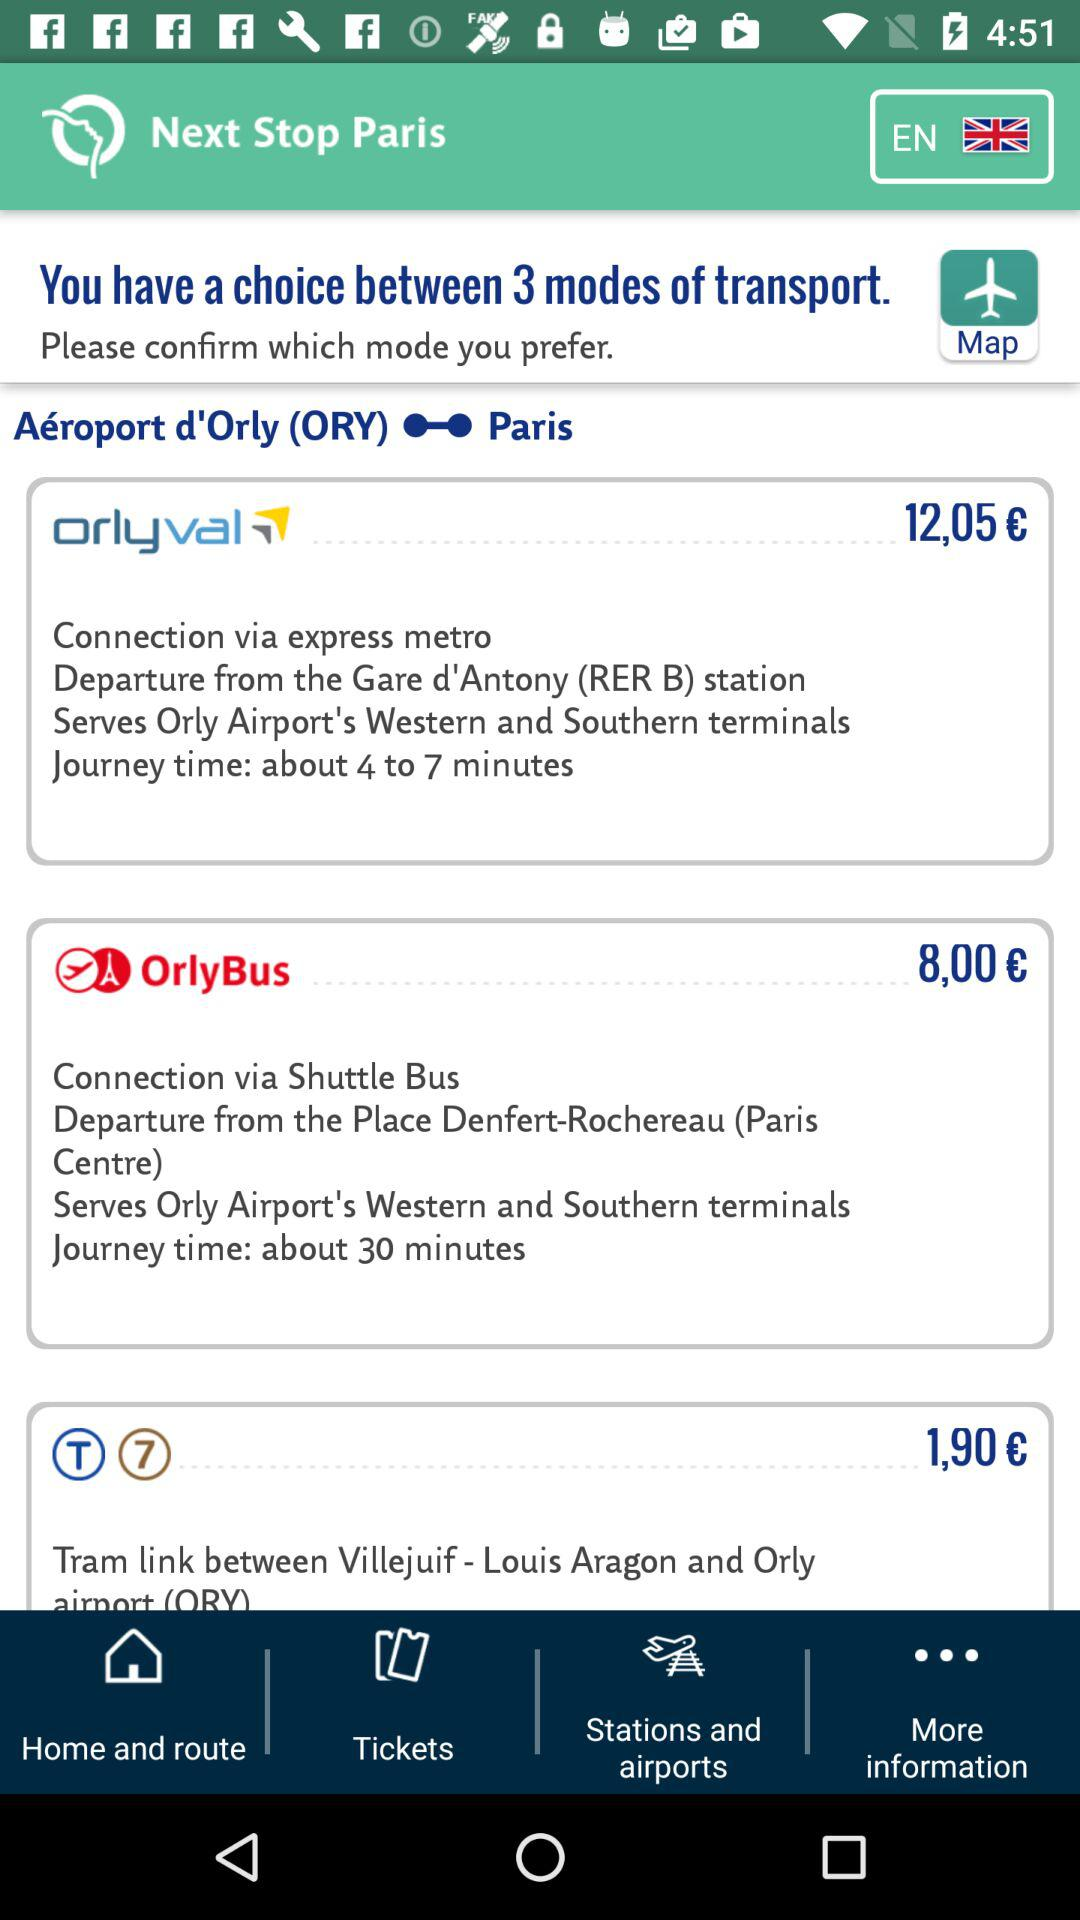From where is the OrlyBus going to depart? The OrlyBus is going to depart from "Denfert-Rochereau (Paris Centre)". 